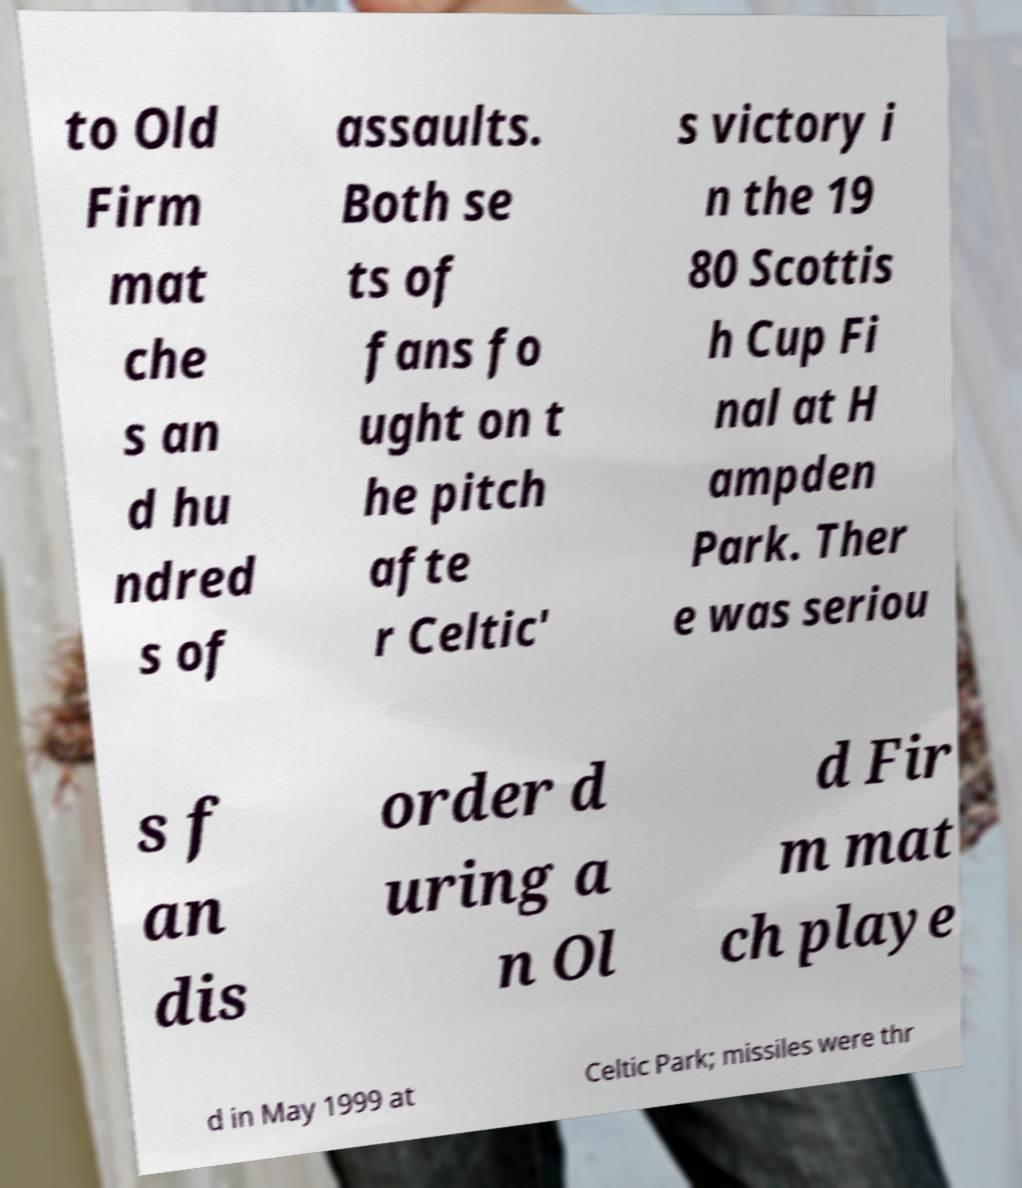Could you extract and type out the text from this image? to Old Firm mat che s an d hu ndred s of assaults. Both se ts of fans fo ught on t he pitch afte r Celtic' s victory i n the 19 80 Scottis h Cup Fi nal at H ampden Park. Ther e was seriou s f an dis order d uring a n Ol d Fir m mat ch playe d in May 1999 at Celtic Park; missiles were thr 